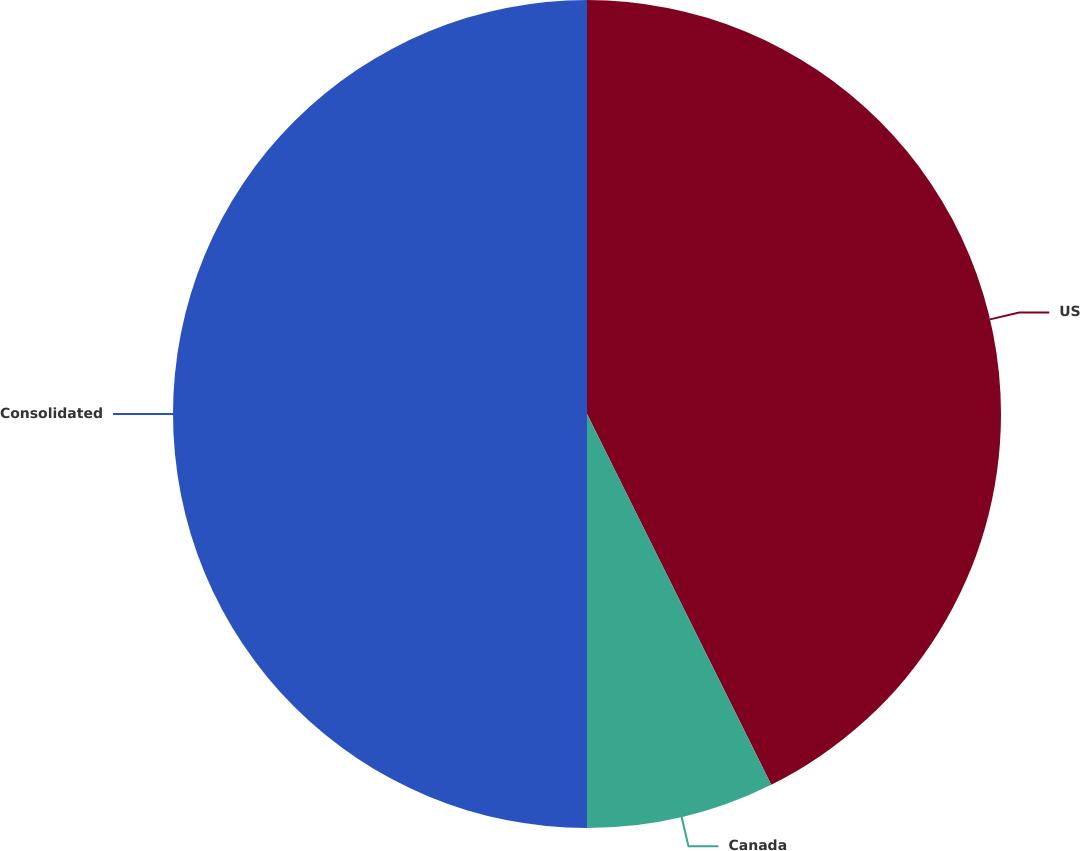Convert chart. <chart><loc_0><loc_0><loc_500><loc_500><pie_chart><fcel>US<fcel>Canada<fcel>Consolidated<nl><fcel>42.66%<fcel>7.34%<fcel>50.0%<nl></chart> 